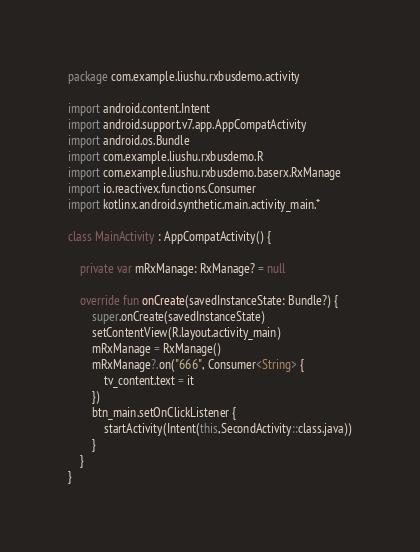Convert code to text. <code><loc_0><loc_0><loc_500><loc_500><_Kotlin_>package com.example.liushu.rxbusdemo.activity

import android.content.Intent
import android.support.v7.app.AppCompatActivity
import android.os.Bundle
import com.example.liushu.rxbusdemo.R
import com.example.liushu.rxbusdemo.baserx.RxManage
import io.reactivex.functions.Consumer
import kotlinx.android.synthetic.main.activity_main.*

class MainActivity : AppCompatActivity() {

    private var mRxManage: RxManage? = null

    override fun onCreate(savedInstanceState: Bundle?) {
        super.onCreate(savedInstanceState)
        setContentView(R.layout.activity_main)
        mRxManage = RxManage()
        mRxManage?.on("666", Consumer<String> {
            tv_content.text = it
        })
        btn_main.setOnClickListener {
            startActivity(Intent(this,SecondActivity::class.java))
        }
    }
}
</code> 